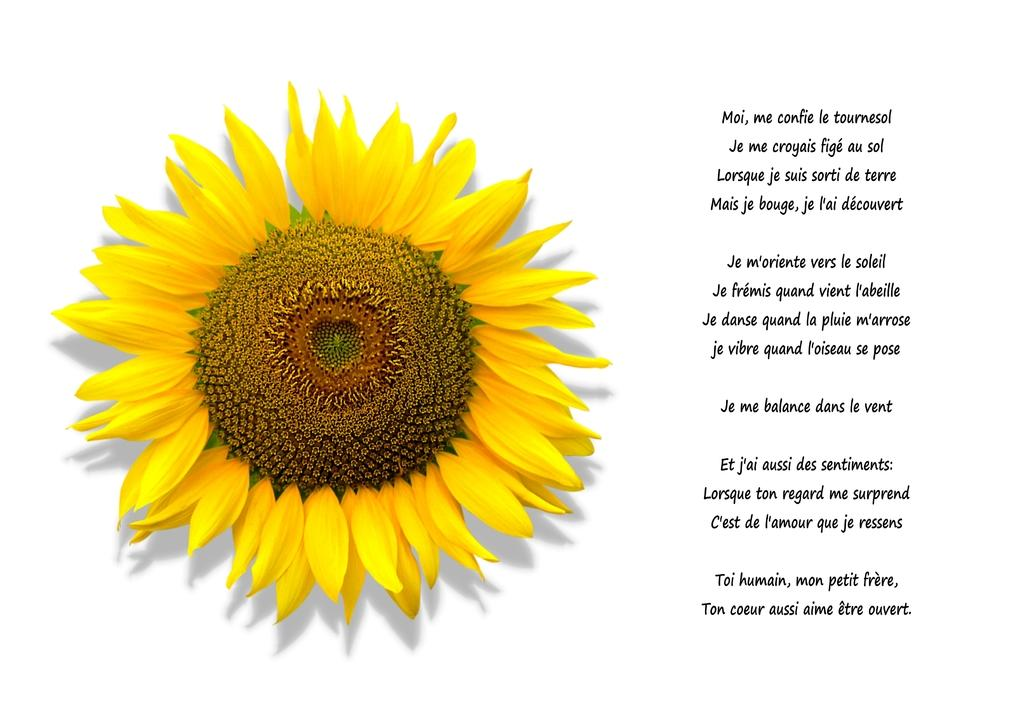What is featured on the poster in the image? There is writing on a poster, and a sunflower is depicted on the poster. What color is the background of the poster? The background of the poster is white. Can you see a rifle leaning against the mailbox in the image? There is no rifle or mailbox present in the image. Is there a baby depicted on the poster? There is no baby depicted on the poster; it features a sunflower. 